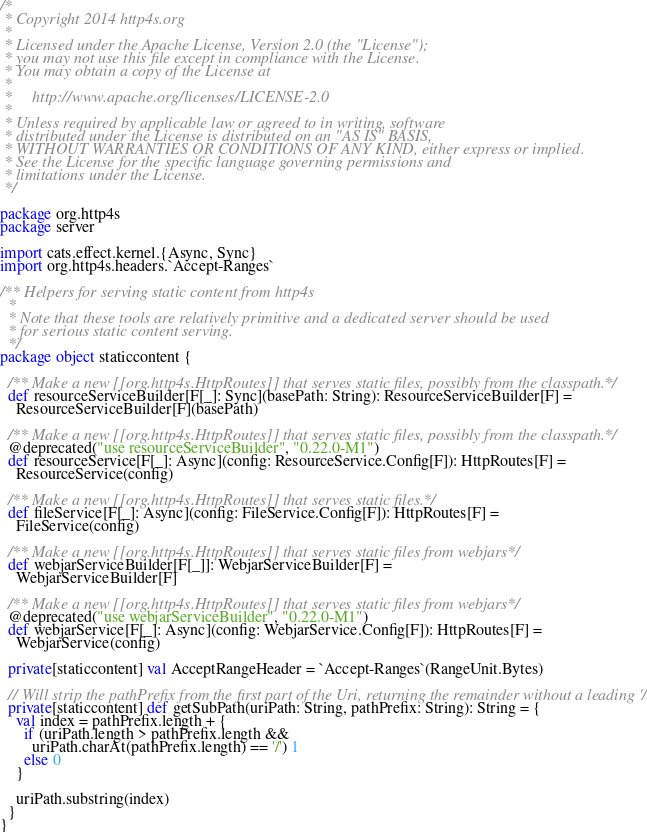<code> <loc_0><loc_0><loc_500><loc_500><_Scala_>/*
 * Copyright 2014 http4s.org
 *
 * Licensed under the Apache License, Version 2.0 (the "License");
 * you may not use this file except in compliance with the License.
 * You may obtain a copy of the License at
 *
 *     http://www.apache.org/licenses/LICENSE-2.0
 *
 * Unless required by applicable law or agreed to in writing, software
 * distributed under the License is distributed on an "AS IS" BASIS,
 * WITHOUT WARRANTIES OR CONDITIONS OF ANY KIND, either express or implied.
 * See the License for the specific language governing permissions and
 * limitations under the License.
 */

package org.http4s
package server

import cats.effect.kernel.{Async, Sync}
import org.http4s.headers.`Accept-Ranges`

/** Helpers for serving static content from http4s
  *
  * Note that these tools are relatively primitive and a dedicated server should be used
  * for serious static content serving.
  */
package object staticcontent {

  /** Make a new [[org.http4s.HttpRoutes]] that serves static files, possibly from the classpath. */
  def resourceServiceBuilder[F[_]: Sync](basePath: String): ResourceServiceBuilder[F] =
    ResourceServiceBuilder[F](basePath)

  /** Make a new [[org.http4s.HttpRoutes]] that serves static files, possibly from the classpath. */
  @deprecated("use resourceServiceBuilder", "0.22.0-M1")
  def resourceService[F[_]: Async](config: ResourceService.Config[F]): HttpRoutes[F] =
    ResourceService(config)

  /** Make a new [[org.http4s.HttpRoutes]] that serves static files. */
  def fileService[F[_]: Async](config: FileService.Config[F]): HttpRoutes[F] =
    FileService(config)

  /** Make a new [[org.http4s.HttpRoutes]] that serves static files from webjars */
  def webjarServiceBuilder[F[_]]: WebjarServiceBuilder[F] =
    WebjarServiceBuilder[F]

  /** Make a new [[org.http4s.HttpRoutes]] that serves static files from webjars */
  @deprecated("use webjarServiceBuilder", "0.22.0-M1")
  def webjarService[F[_]: Async](config: WebjarService.Config[F]): HttpRoutes[F] =
    WebjarService(config)

  private[staticcontent] val AcceptRangeHeader = `Accept-Ranges`(RangeUnit.Bytes)

  // Will strip the pathPrefix from the first part of the Uri, returning the remainder without a leading '/'
  private[staticcontent] def getSubPath(uriPath: String, pathPrefix: String): String = {
    val index = pathPrefix.length + {
      if (uriPath.length > pathPrefix.length &&
        uriPath.charAt(pathPrefix.length) == '/') 1
      else 0
    }

    uriPath.substring(index)
  }
}
</code> 